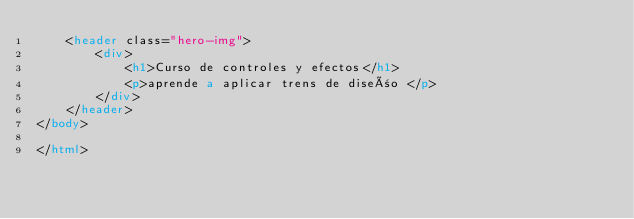<code> <loc_0><loc_0><loc_500><loc_500><_HTML_>    <header class="hero-img">
        <div>
            <h1>Curso de controles y efectos</h1>
            <p>aprende a aplicar trens de diseño </p>
        </div>
    </header>
</body>

</html></code> 